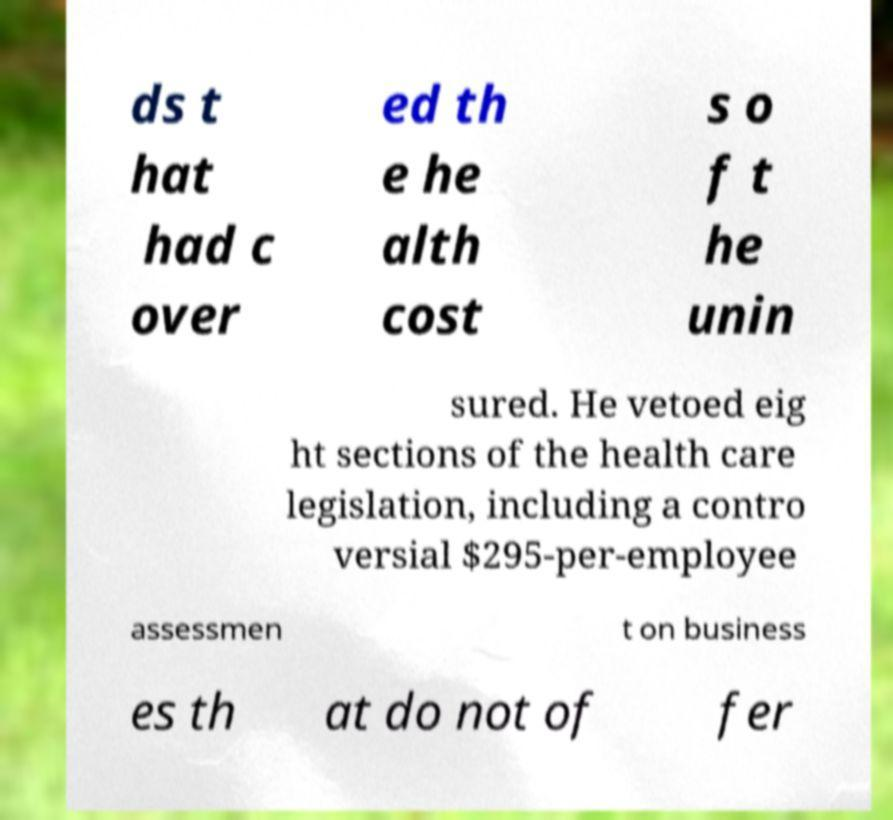For documentation purposes, I need the text within this image transcribed. Could you provide that? ds t hat had c over ed th e he alth cost s o f t he unin sured. He vetoed eig ht sections of the health care legislation, including a contro versial $295-per-employee assessmen t on business es th at do not of fer 